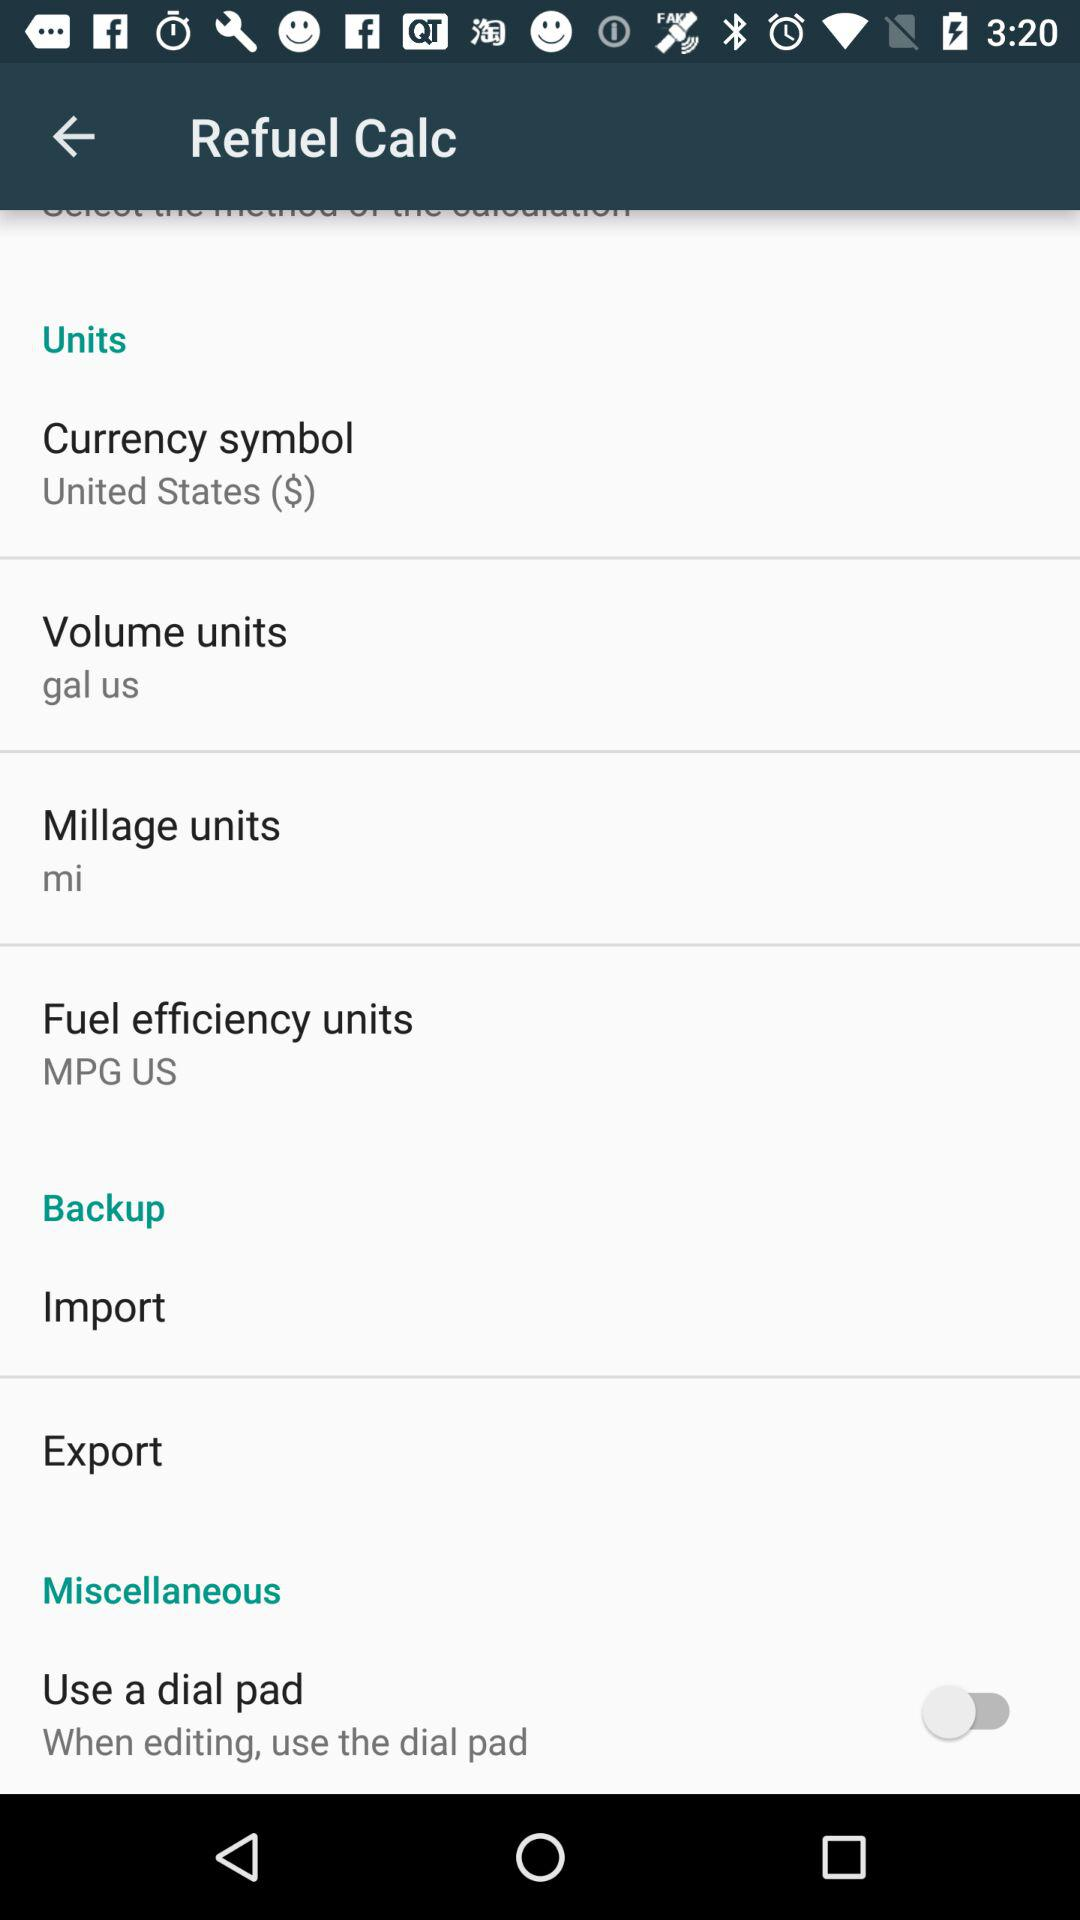What's the fuel efficiency unit? The fuel efficiency unit is MPG US. 